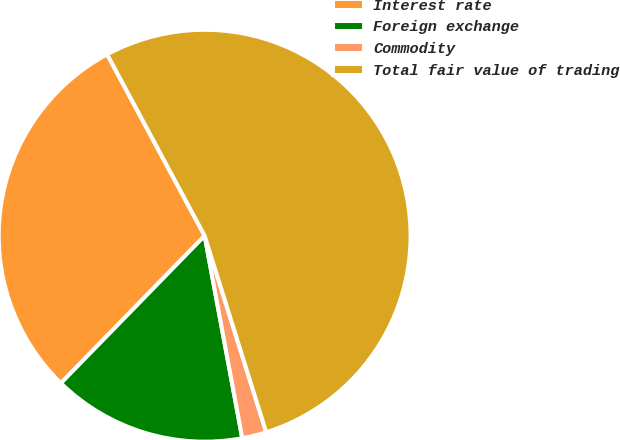Convert chart to OTSL. <chart><loc_0><loc_0><loc_500><loc_500><pie_chart><fcel>Interest rate<fcel>Foreign exchange<fcel>Commodity<fcel>Total fair value of trading<nl><fcel>29.85%<fcel>15.22%<fcel>1.91%<fcel>53.01%<nl></chart> 